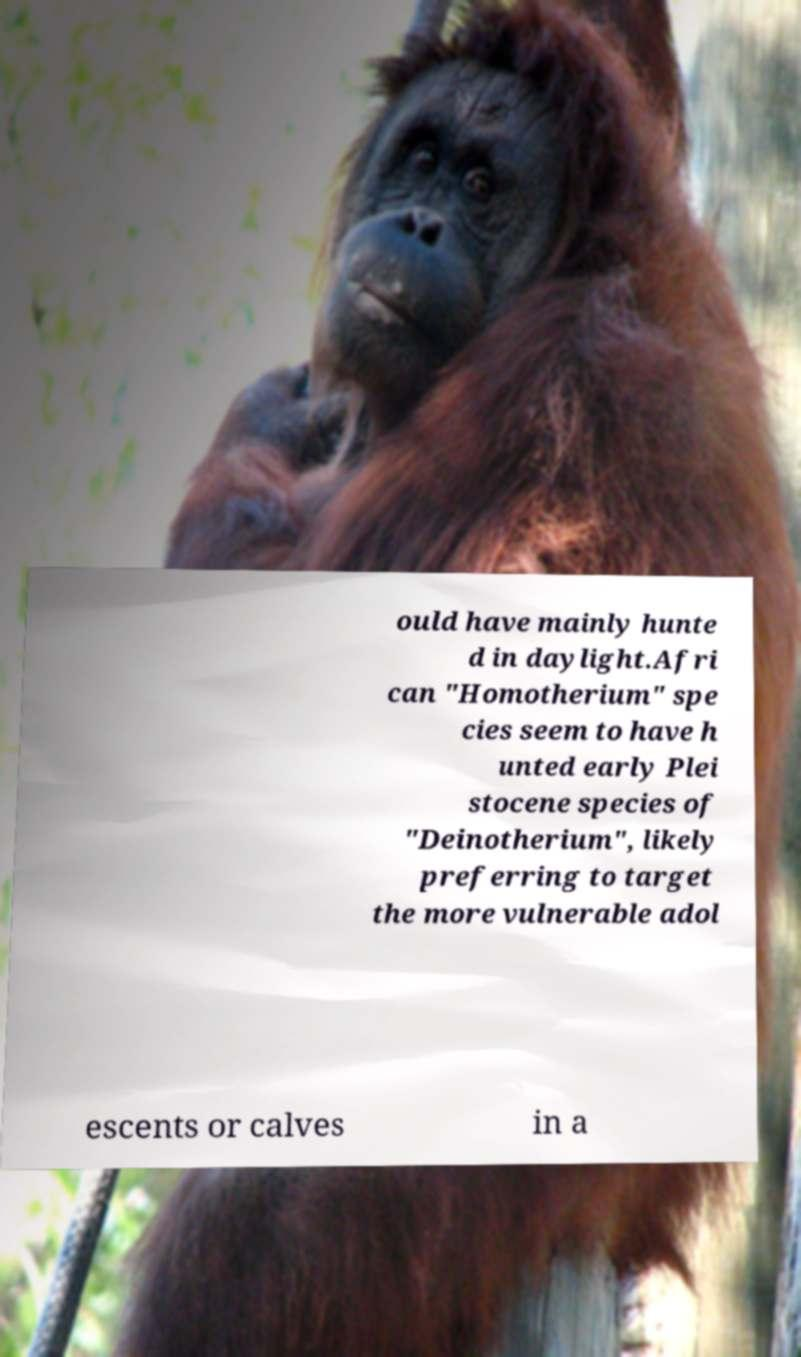Please read and relay the text visible in this image. What does it say? ould have mainly hunte d in daylight.Afri can "Homotherium" spe cies seem to have h unted early Plei stocene species of "Deinotherium", likely preferring to target the more vulnerable adol escents or calves in a 